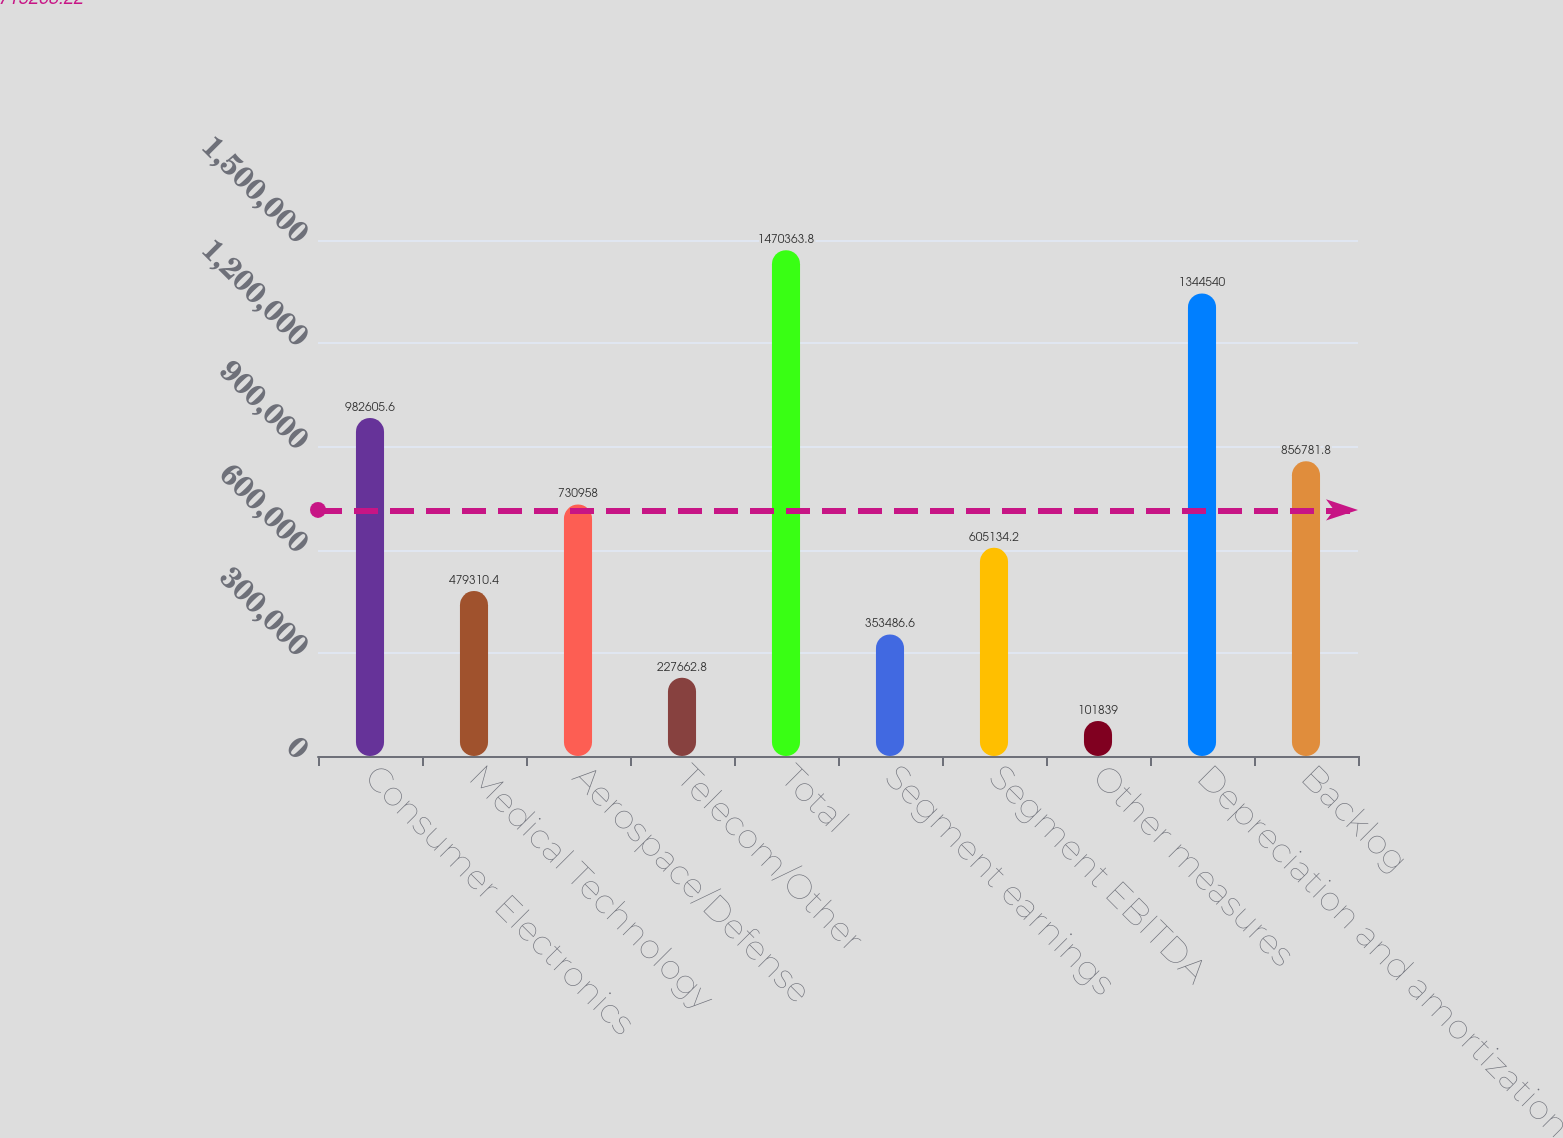Convert chart to OTSL. <chart><loc_0><loc_0><loc_500><loc_500><bar_chart><fcel>Consumer Electronics<fcel>Medical Technology<fcel>Aerospace/Defense<fcel>Telecom/Other<fcel>Total<fcel>Segment earnings<fcel>Segment EBITDA<fcel>Other measures<fcel>Depreciation and amortization<fcel>Backlog<nl><fcel>982606<fcel>479310<fcel>730958<fcel>227663<fcel>1.47036e+06<fcel>353487<fcel>605134<fcel>101839<fcel>1.34454e+06<fcel>856782<nl></chart> 